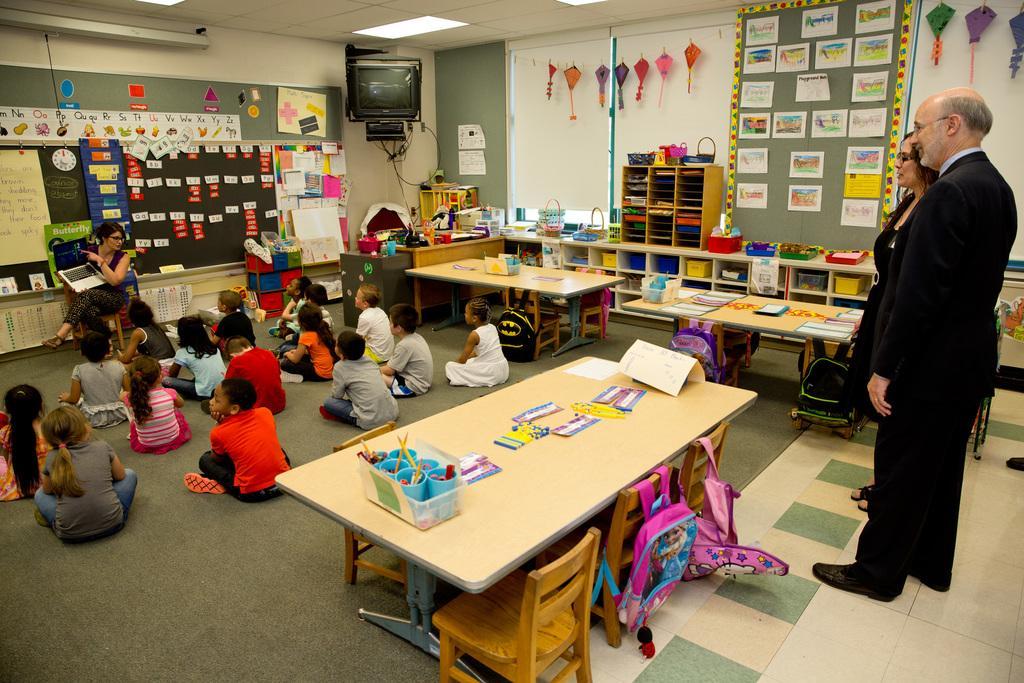Please provide a concise description of this image. There are few children sitting on the floor, a woman sitting on the chair holding a laptop an teaching the children. The man and the woman standing are listing. There are few glasses, papers on the table,there are two bags attached to a chair,there are few papers attached to the wall and there are few kites hanging to a pole. At the background there is a television,at the top there is a light. 